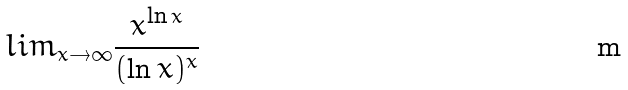<formula> <loc_0><loc_0><loc_500><loc_500>l i m _ { x \rightarrow \infty } \frac { x ^ { \ln x } } { ( \ln x ) ^ { x } }</formula> 